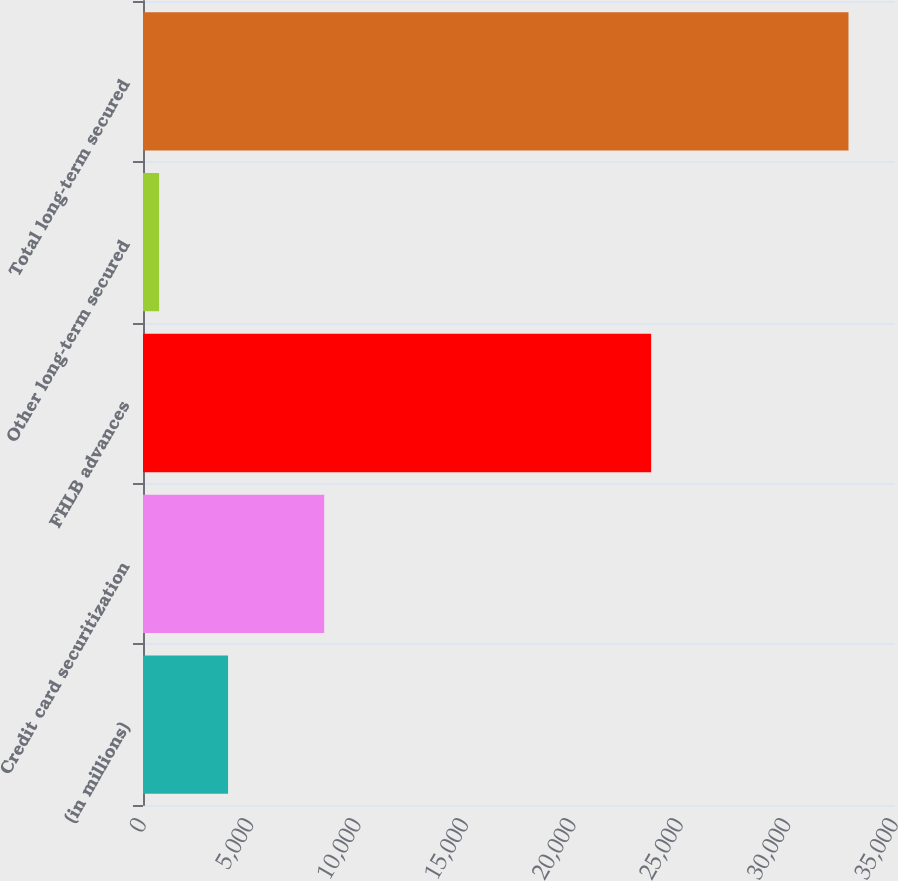Convert chart. <chart><loc_0><loc_0><loc_500><loc_500><bar_chart><fcel>(in millions)<fcel>Credit card securitization<fcel>FHLB advances<fcel>Other long-term secured<fcel>Total long-term secured<nl><fcel>3959.4<fcel>8434<fcel>23650<fcel>751<fcel>32835<nl></chart> 